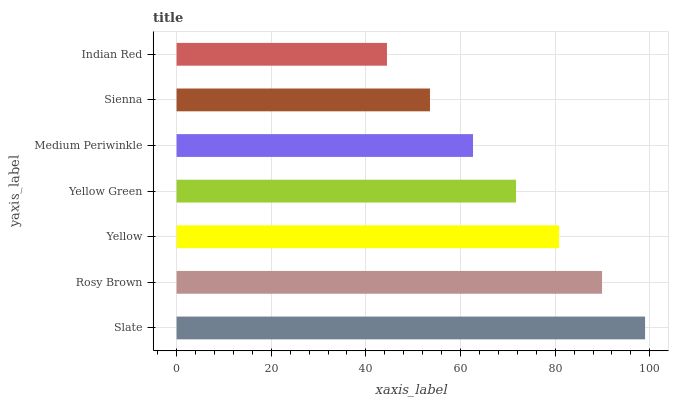Is Indian Red the minimum?
Answer yes or no. Yes. Is Slate the maximum?
Answer yes or no. Yes. Is Rosy Brown the minimum?
Answer yes or no. No. Is Rosy Brown the maximum?
Answer yes or no. No. Is Slate greater than Rosy Brown?
Answer yes or no. Yes. Is Rosy Brown less than Slate?
Answer yes or no. Yes. Is Rosy Brown greater than Slate?
Answer yes or no. No. Is Slate less than Rosy Brown?
Answer yes or no. No. Is Yellow Green the high median?
Answer yes or no. Yes. Is Yellow Green the low median?
Answer yes or no. Yes. Is Rosy Brown the high median?
Answer yes or no. No. Is Medium Periwinkle the low median?
Answer yes or no. No. 